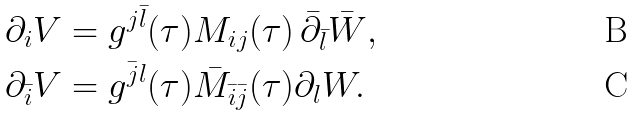<formula> <loc_0><loc_0><loc_500><loc_500>\partial _ { i } V & = g ^ { j \bar { l } } ( \tau ) M _ { i j } ( \tau ) \, \bar { \partial } _ { \bar { l } } \bar { W } , \\ \partial _ { \bar { i } } V & = g ^ { \bar { j } l } ( \tau ) \bar { M } _ { \bar { i } \bar { j } } ( \tau ) \partial _ { l } W .</formula> 